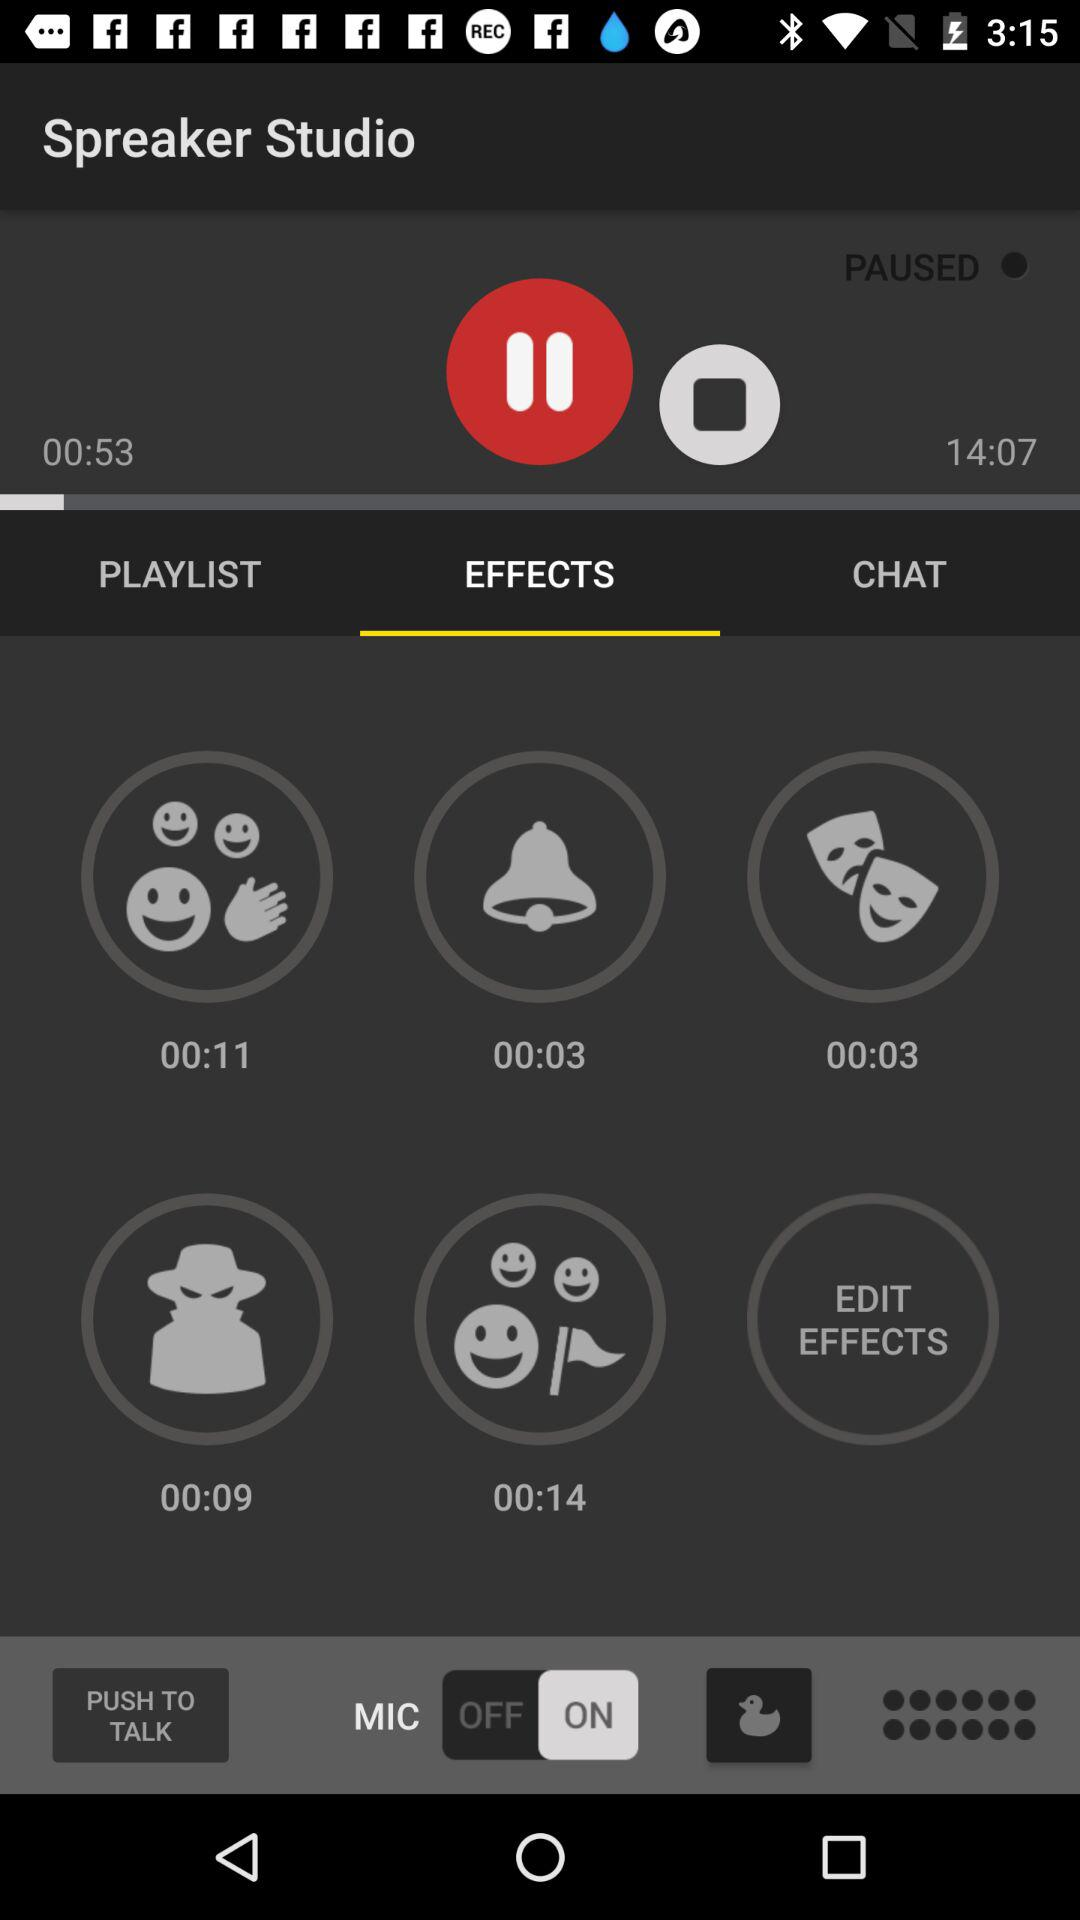Which option is selected for "Spreaker Studio"? The selected option is "EFFECTS". 